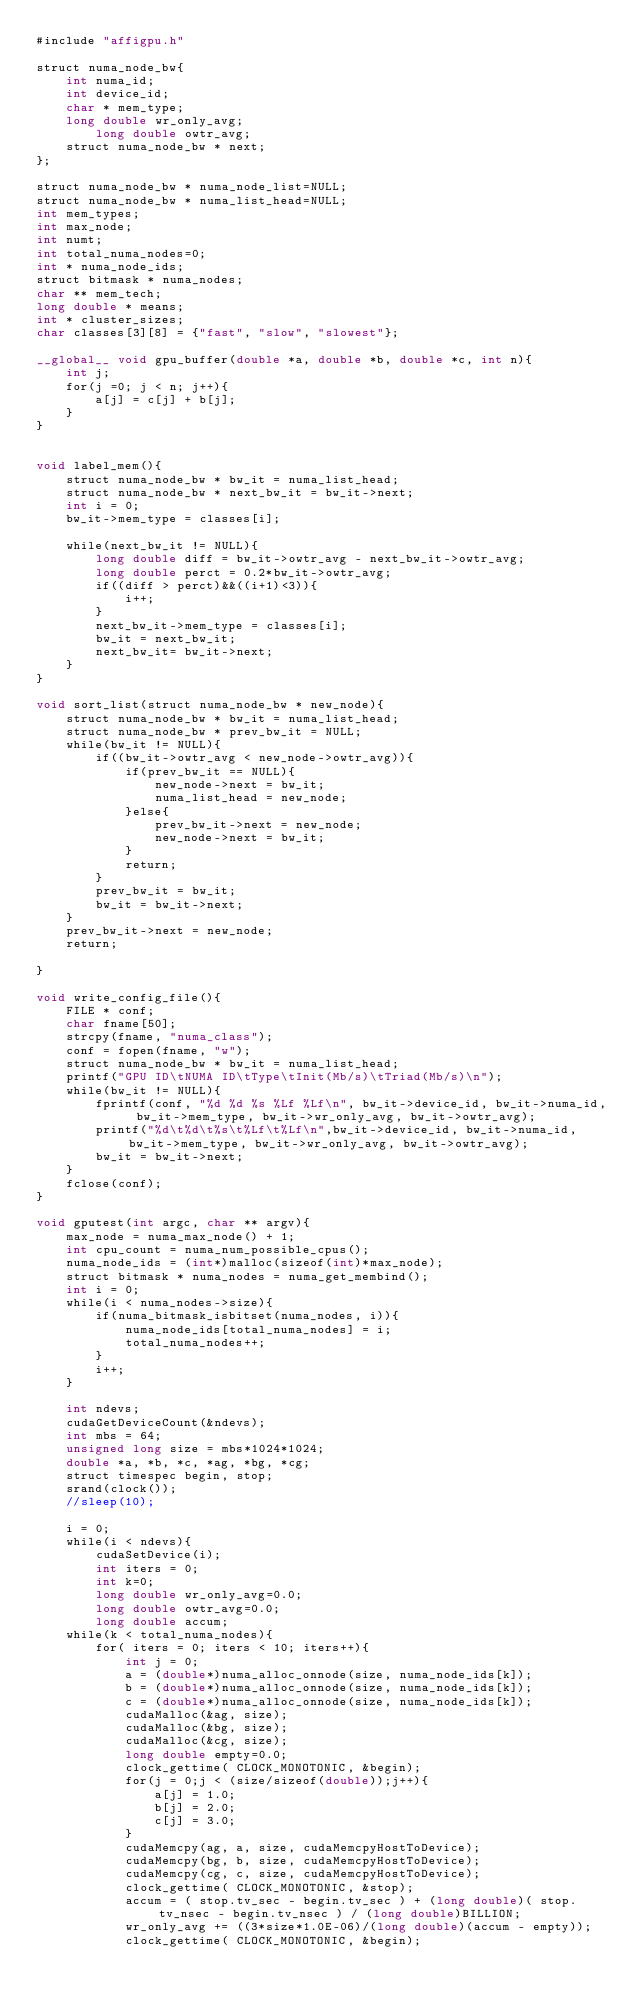Convert code to text. <code><loc_0><loc_0><loc_500><loc_500><_Cuda_>#include "affigpu.h"

struct numa_node_bw{
	int numa_id;
	int device_id;
	char * mem_type;
	long double wr_only_avg;
        long double owtr_avg;
	struct numa_node_bw * next;
};

struct numa_node_bw * numa_node_list=NULL;
struct numa_node_bw * numa_list_head=NULL;
int mem_types;
int max_node;
int numt;
int total_numa_nodes=0;
int * numa_node_ids;
struct bitmask * numa_nodes;
char ** mem_tech;
long double * means;
int * cluster_sizes;
char classes[3][8] = {"fast", "slow", "slowest"};

__global__ void gpu_buffer(double *a, double *b, double *c, int n){
	int j;
	for(j =0; j < n; j++){
		a[j] = c[j] + b[j];
	}
}


void label_mem(){
	struct numa_node_bw * bw_it = numa_list_head;
	struct numa_node_bw * next_bw_it = bw_it->next;
	int i = 0;
	bw_it->mem_type = classes[i];
	
	while(next_bw_it != NULL){
		long double diff = bw_it->owtr_avg - next_bw_it->owtr_avg;
		long double perct = 0.2*bw_it->owtr_avg;
		if((diff > perct)&&((i+1)<3)){
			i++;
		}
		next_bw_it->mem_type = classes[i];
		bw_it = next_bw_it;
		next_bw_it= bw_it->next;
	}
}

void sort_list(struct numa_node_bw * new_node){
	struct numa_node_bw * bw_it = numa_list_head;
	struct numa_node_bw * prev_bw_it = NULL;
	while(bw_it != NULL){
		if((bw_it->owtr_avg < new_node->owtr_avg)){
			if(prev_bw_it == NULL){
				new_node->next = bw_it;
				numa_list_head = new_node;
			}else{
				prev_bw_it->next = new_node;
				new_node->next = bw_it;
			}
			return;
		}
		prev_bw_it = bw_it;
		bw_it = bw_it->next;
	}
	prev_bw_it->next = new_node;
	return;

}

void write_config_file(){
	FILE * conf;
	char fname[50];
	strcpy(fname, "numa_class");
	conf = fopen(fname, "w");
	struct numa_node_bw * bw_it = numa_list_head;
	printf("GPU ID\tNUMA ID\tType\tInit(Mb/s)\tTriad(Mb/s)\n");
	while(bw_it != NULL){	
		fprintf(conf, "%d %d %s %Lf %Lf\n", bw_it->device_id, bw_it->numa_id, bw_it->mem_type, bw_it->wr_only_avg, bw_it->owtr_avg);
		printf("%d\t%d\t%s\t%Lf\t%Lf\n",bw_it->device_id, bw_it->numa_id, bw_it->mem_type, bw_it->wr_only_avg, bw_it->owtr_avg);
		bw_it = bw_it->next;
	}
	fclose(conf);
}

void gputest(int argc, char ** argv){
	max_node = numa_max_node() + 1;
	int cpu_count = numa_num_possible_cpus();
	numa_node_ids = (int*)malloc(sizeof(int)*max_node);
	struct bitmask * numa_nodes = numa_get_membind();
	int i = 0;
	while(i < numa_nodes->size){
		if(numa_bitmask_isbitset(numa_nodes, i)){
			numa_node_ids[total_numa_nodes] = i;
			total_numa_nodes++;
		}
		i++;
	}

	int ndevs;
	cudaGetDeviceCount(&ndevs);
	int mbs = 64;
	unsigned long size = mbs*1024*1024;
	double *a, *b, *c, *ag, *bg, *cg;
	struct timespec begin, stop;
	srand(clock());
	//sleep(10);
 
 	i = 0;
	while(i < ndevs){
		cudaSetDevice(i);
		int iters = 0;
		int k=0;
		long double wr_only_avg=0.0;
		long double owtr_avg=0.0;
		long double accum;
	while(k < total_numa_nodes){
		for( iters = 0; iters < 10; iters++){
			int j = 0;
			a = (double*)numa_alloc_onnode(size, numa_node_ids[k]);
			b = (double*)numa_alloc_onnode(size, numa_node_ids[k]);
			c = (double*)numa_alloc_onnode(size, numa_node_ids[k]);
			cudaMalloc(&ag, size);
			cudaMalloc(&bg, size);
			cudaMalloc(&cg, size);
			long double empty=0.0;
			clock_gettime( CLOCK_MONOTONIC, &begin);
			for(j = 0;j < (size/sizeof(double));j++){
				a[j] = 1.0;
				b[j] = 2.0;
				c[j] = 3.0;
			}
			cudaMemcpy(ag, a, size, cudaMemcpyHostToDevice);
			cudaMemcpy(bg, b, size, cudaMemcpyHostToDevice);
			cudaMemcpy(cg, c, size, cudaMemcpyHostToDevice);
			clock_gettime( CLOCK_MONOTONIC, &stop);
			accum = ( stop.tv_sec - begin.tv_sec ) + (long double)( stop.tv_nsec - begin.tv_nsec ) / (long double)BILLION;
			wr_only_avg += ((3*size*1.0E-06)/(long double)(accum - empty));
			clock_gettime( CLOCK_MONOTONIC, &begin);</code> 